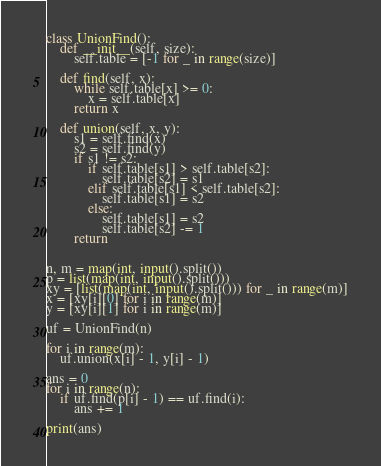<code> <loc_0><loc_0><loc_500><loc_500><_Python_>class UnionFind():
	def __init__(self, size):
		self.table = [-1 for _ in range(size)]

	def find(self, x):
		while self.table[x] >= 0:
			x = self.table[x]
		return x

	def union(self, x, y):
		s1 = self.find(x)
		s2 = self.find(y)
		if s1 != s2:
			if self.table[s1] > self.table[s2]:
				self.table[s2] = s1
			elif self.table[s1] < self.table[s2]:
				self.table[s1] = s2
			else:
				self.table[s1] = s2
				self.table[s2] -= 1
		return


n, m = map(int, input().split())
p = list(map(int, input().split()))
xy = [list(map(int, input().split())) for _ in range(m)]
x = [xy[i][0] for i in range(m)]
y = [xy[i][1] for i in range(m)]

uf = UnionFind(n)

for i in range(m):
	uf.union(x[i] - 1, y[i] - 1)

ans = 0
for i in range(n):
	if uf.find(p[i] - 1) == uf.find(i):
		ans += 1

print(ans)</code> 